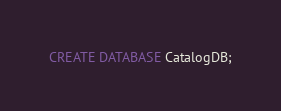Convert code to text. <code><loc_0><loc_0><loc_500><loc_500><_SQL_>CREATE DATABASE CatalogDB;


</code> 